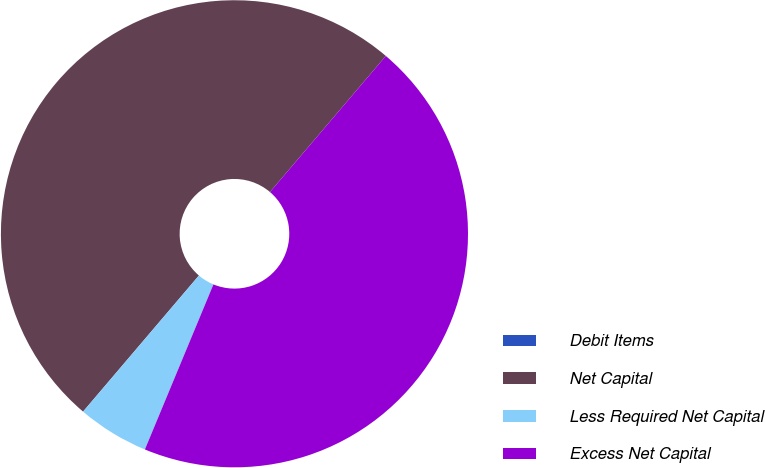Convert chart to OTSL. <chart><loc_0><loc_0><loc_500><loc_500><pie_chart><fcel>Debit Items<fcel>Net Capital<fcel>Less Required Net Capital<fcel>Excess Net Capital<nl><fcel>0.0%<fcel>50.0%<fcel>4.96%<fcel>45.04%<nl></chart> 